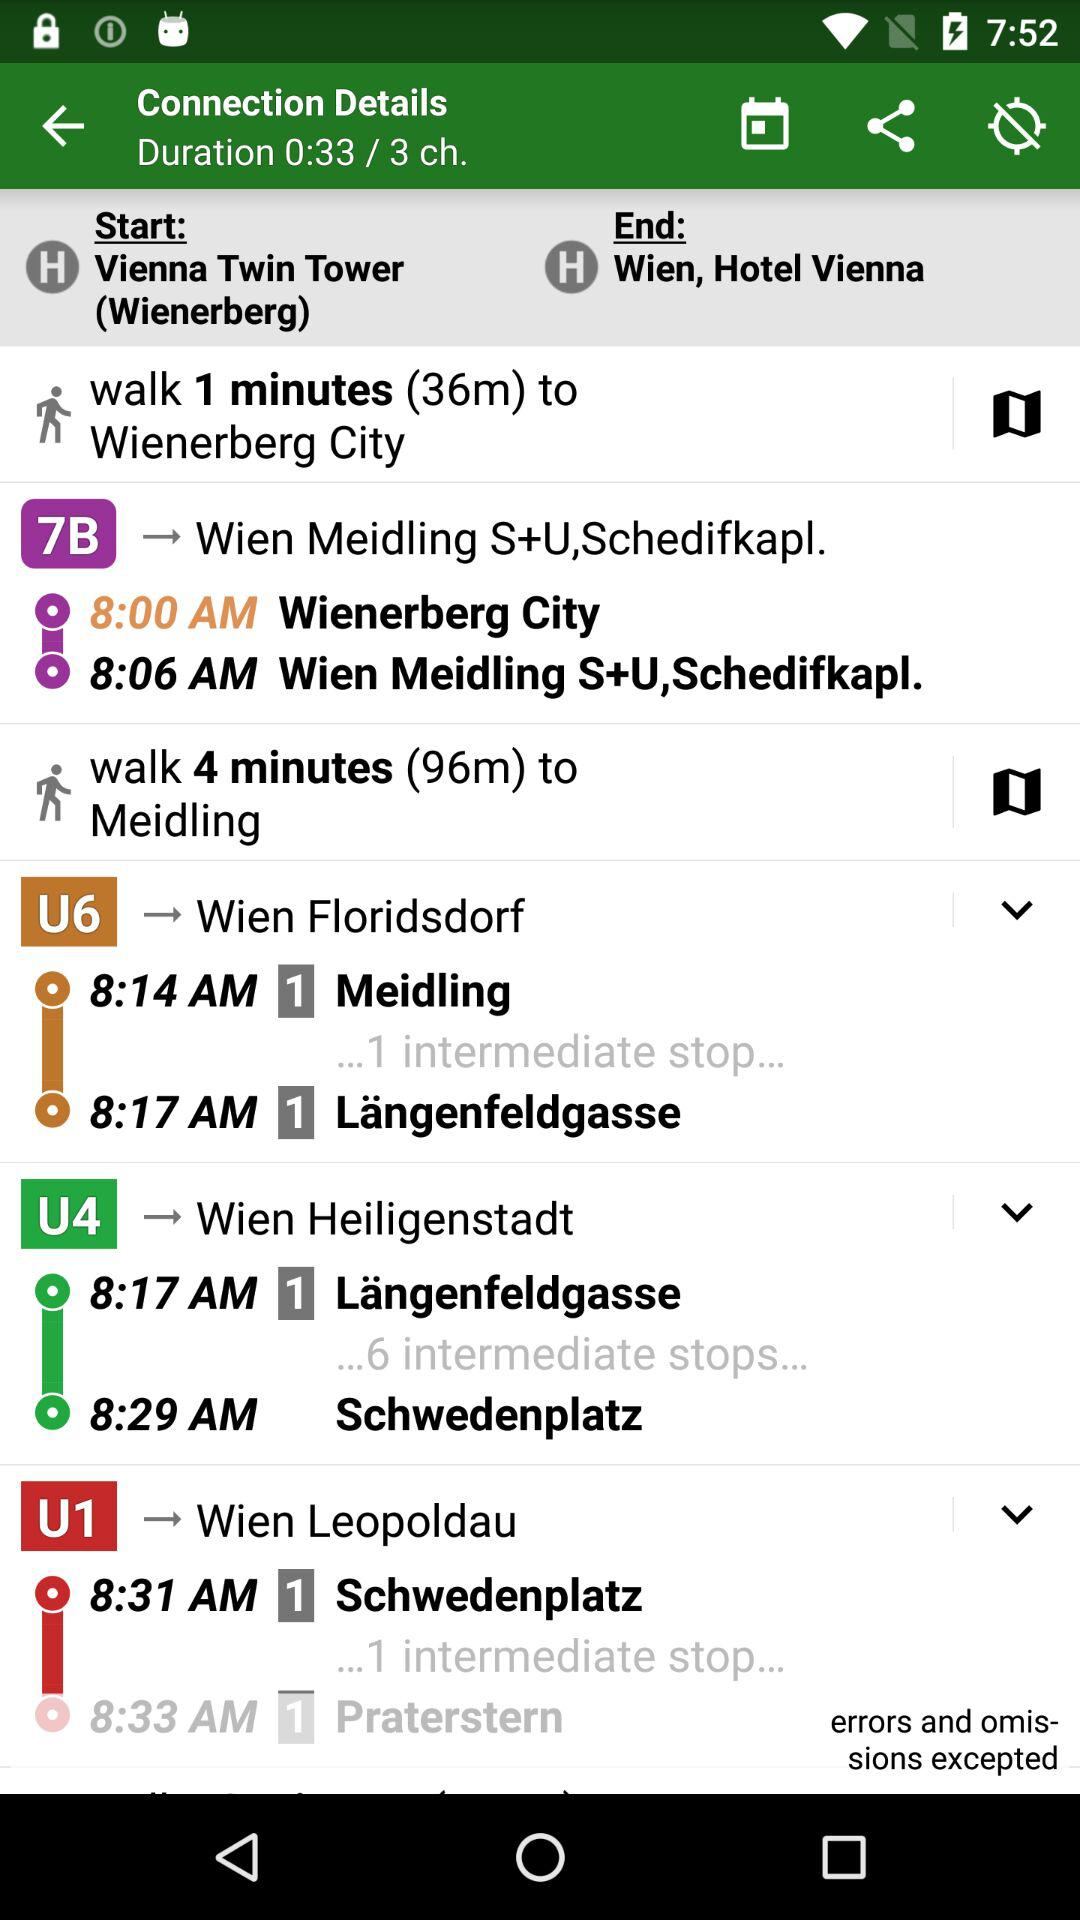What is the start location? The start location is the Vienna Twin Tower (Wienerberg). 